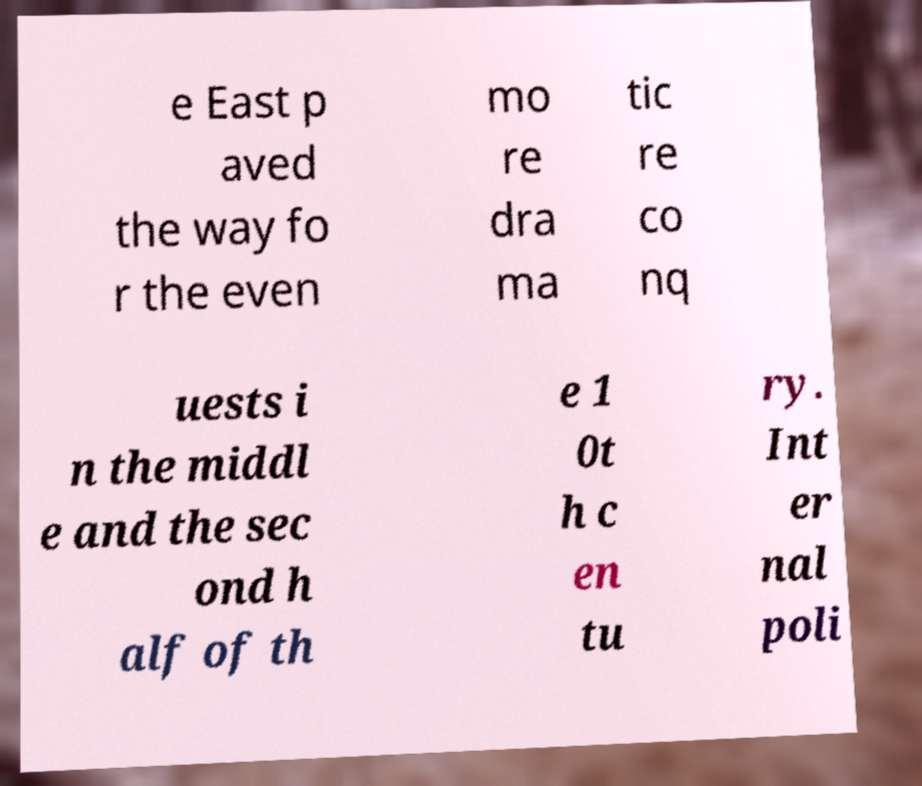Can you accurately transcribe the text from the provided image for me? e East p aved the way fo r the even mo re dra ma tic re co nq uests i n the middl e and the sec ond h alf of th e 1 0t h c en tu ry. Int er nal poli 